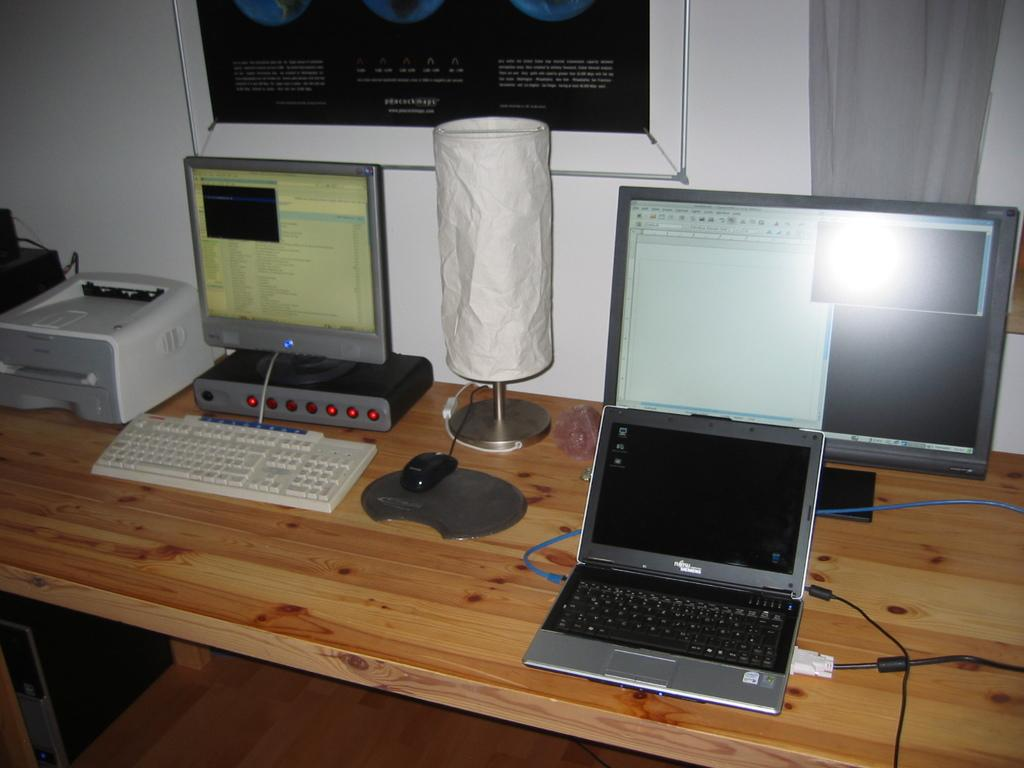What type of furniture is present in the image? There is a table in the image. What electronic devices are on the table? There are monitors, a keyboard, a mouse, and a laptop on the table. What other computer component is visible in the image? There is a CPU in the image. What is the background of the image like? There is a wall and a frame in the background of the image. Can you describe the floor in the image? The floor is visible in the image. What type of gate can be seen in the image? There is no gate present in the image. Can you describe the pail used for watering plants in the image? There is no pail or plants present in the image. 